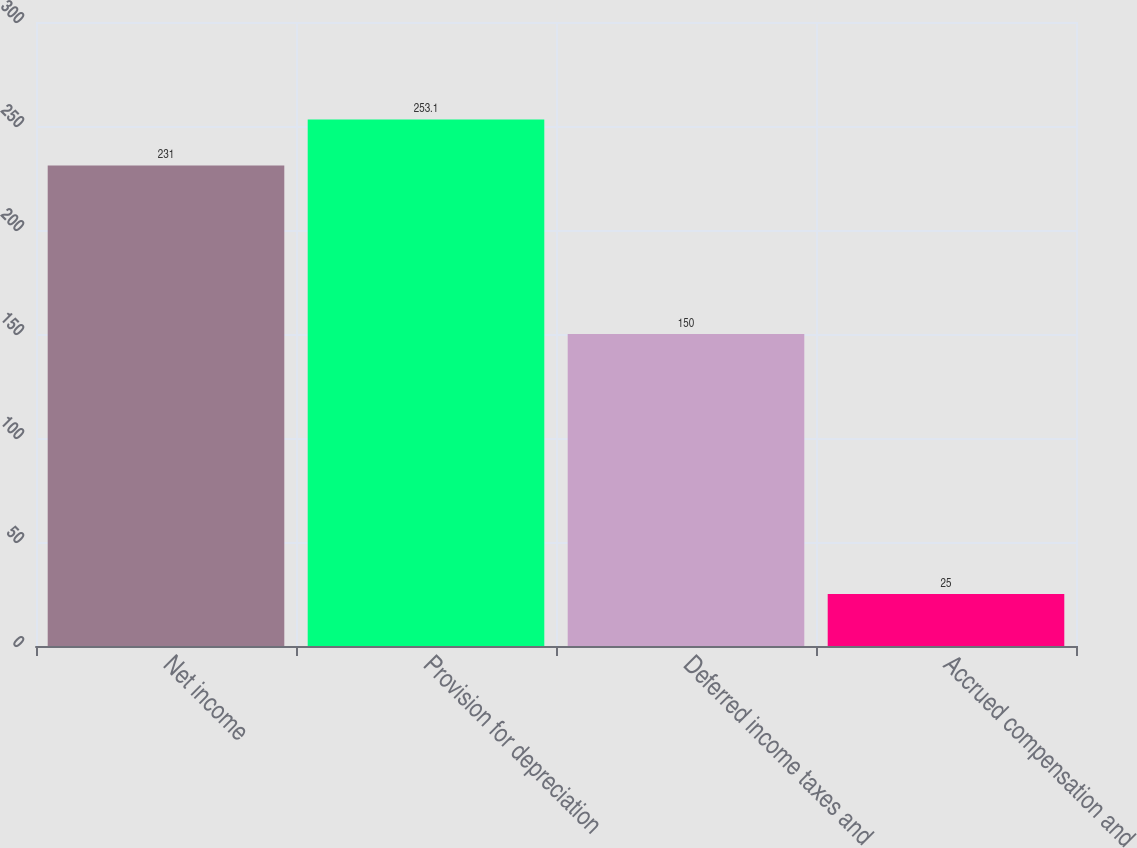Convert chart. <chart><loc_0><loc_0><loc_500><loc_500><bar_chart><fcel>Net income<fcel>Provision for depreciation<fcel>Deferred income taxes and<fcel>Accrued compensation and<nl><fcel>231<fcel>253.1<fcel>150<fcel>25<nl></chart> 